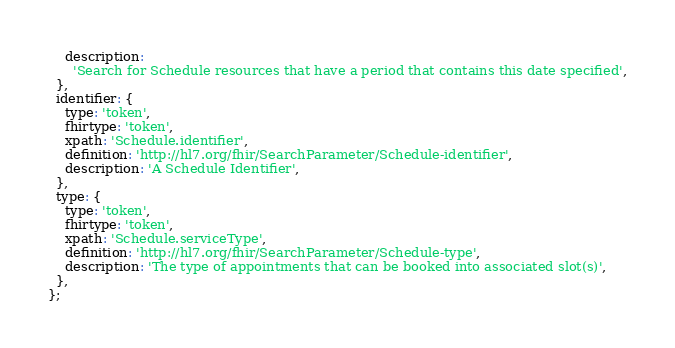<code> <loc_0><loc_0><loc_500><loc_500><_JavaScript_>    description:
      'Search for Schedule resources that have a period that contains this date specified',
  },
  identifier: {
    type: 'token',
    fhirtype: 'token',
    xpath: 'Schedule.identifier',
    definition: 'http://hl7.org/fhir/SearchParameter/Schedule-identifier',
    description: 'A Schedule Identifier',
  },
  type: {
    type: 'token',
    fhirtype: 'token',
    xpath: 'Schedule.serviceType',
    definition: 'http://hl7.org/fhir/SearchParameter/Schedule-type',
    description: 'The type of appointments that can be booked into associated slot(s)',
  },
};
</code> 